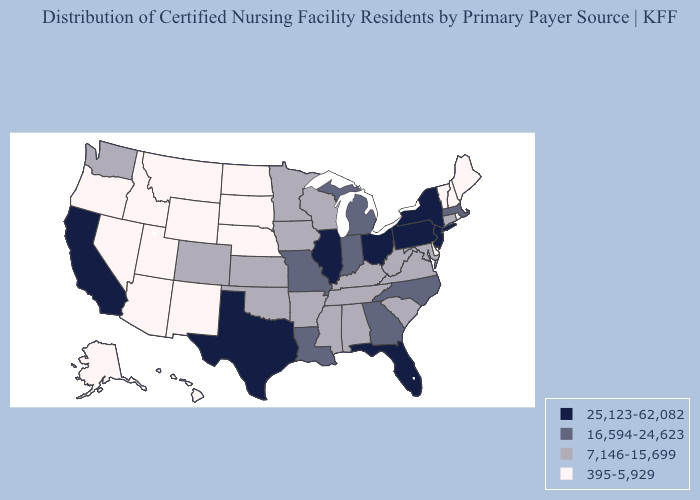What is the highest value in the Northeast ?
Quick response, please. 25,123-62,082. What is the highest value in the South ?
Be succinct. 25,123-62,082. Which states have the lowest value in the USA?
Answer briefly. Alaska, Arizona, Delaware, Hawaii, Idaho, Maine, Montana, Nebraska, Nevada, New Hampshire, New Mexico, North Dakota, Oregon, Rhode Island, South Dakota, Utah, Vermont, Wyoming. Does Virginia have a higher value than Maryland?
Give a very brief answer. No. Name the states that have a value in the range 7,146-15,699?
Give a very brief answer. Alabama, Arkansas, Colorado, Connecticut, Iowa, Kansas, Kentucky, Maryland, Minnesota, Mississippi, Oklahoma, South Carolina, Tennessee, Virginia, Washington, West Virginia, Wisconsin. Among the states that border Massachusetts , which have the highest value?
Answer briefly. New York. Name the states that have a value in the range 16,594-24,623?
Give a very brief answer. Georgia, Indiana, Louisiana, Massachusetts, Michigan, Missouri, North Carolina. Among the states that border Kentucky , which have the highest value?
Answer briefly. Illinois, Ohio. Does Wyoming have the same value as New Mexico?
Short answer required. Yes. What is the value of South Dakota?
Give a very brief answer. 395-5,929. Name the states that have a value in the range 7,146-15,699?
Answer briefly. Alabama, Arkansas, Colorado, Connecticut, Iowa, Kansas, Kentucky, Maryland, Minnesota, Mississippi, Oklahoma, South Carolina, Tennessee, Virginia, Washington, West Virginia, Wisconsin. What is the highest value in the USA?
Answer briefly. 25,123-62,082. What is the highest value in the MidWest ?
Give a very brief answer. 25,123-62,082. What is the lowest value in states that border South Dakota?
Quick response, please. 395-5,929. What is the value of Arizona?
Quick response, please. 395-5,929. 